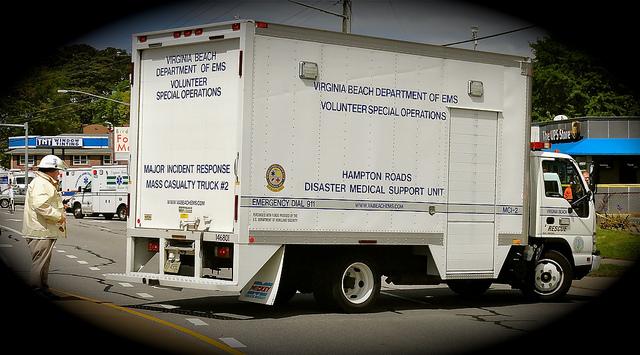Is this truck backing up?
Write a very short answer. Yes. What is the website written on the van?
Keep it brief. None. How many wheels does the large truck have?
Quick response, please. 6. Is the truck arriving at its destination or leaving its destination?
Concise answer only. Arriving. What is in the trailer in the foreground?
Concise answer only. Medical equipment. What is this truck used for?
Answer briefly. Medical. What is the track transporting?
Give a very brief answer. Medical supplies. What are these people holding on to?
Answer briefly. Hope. 